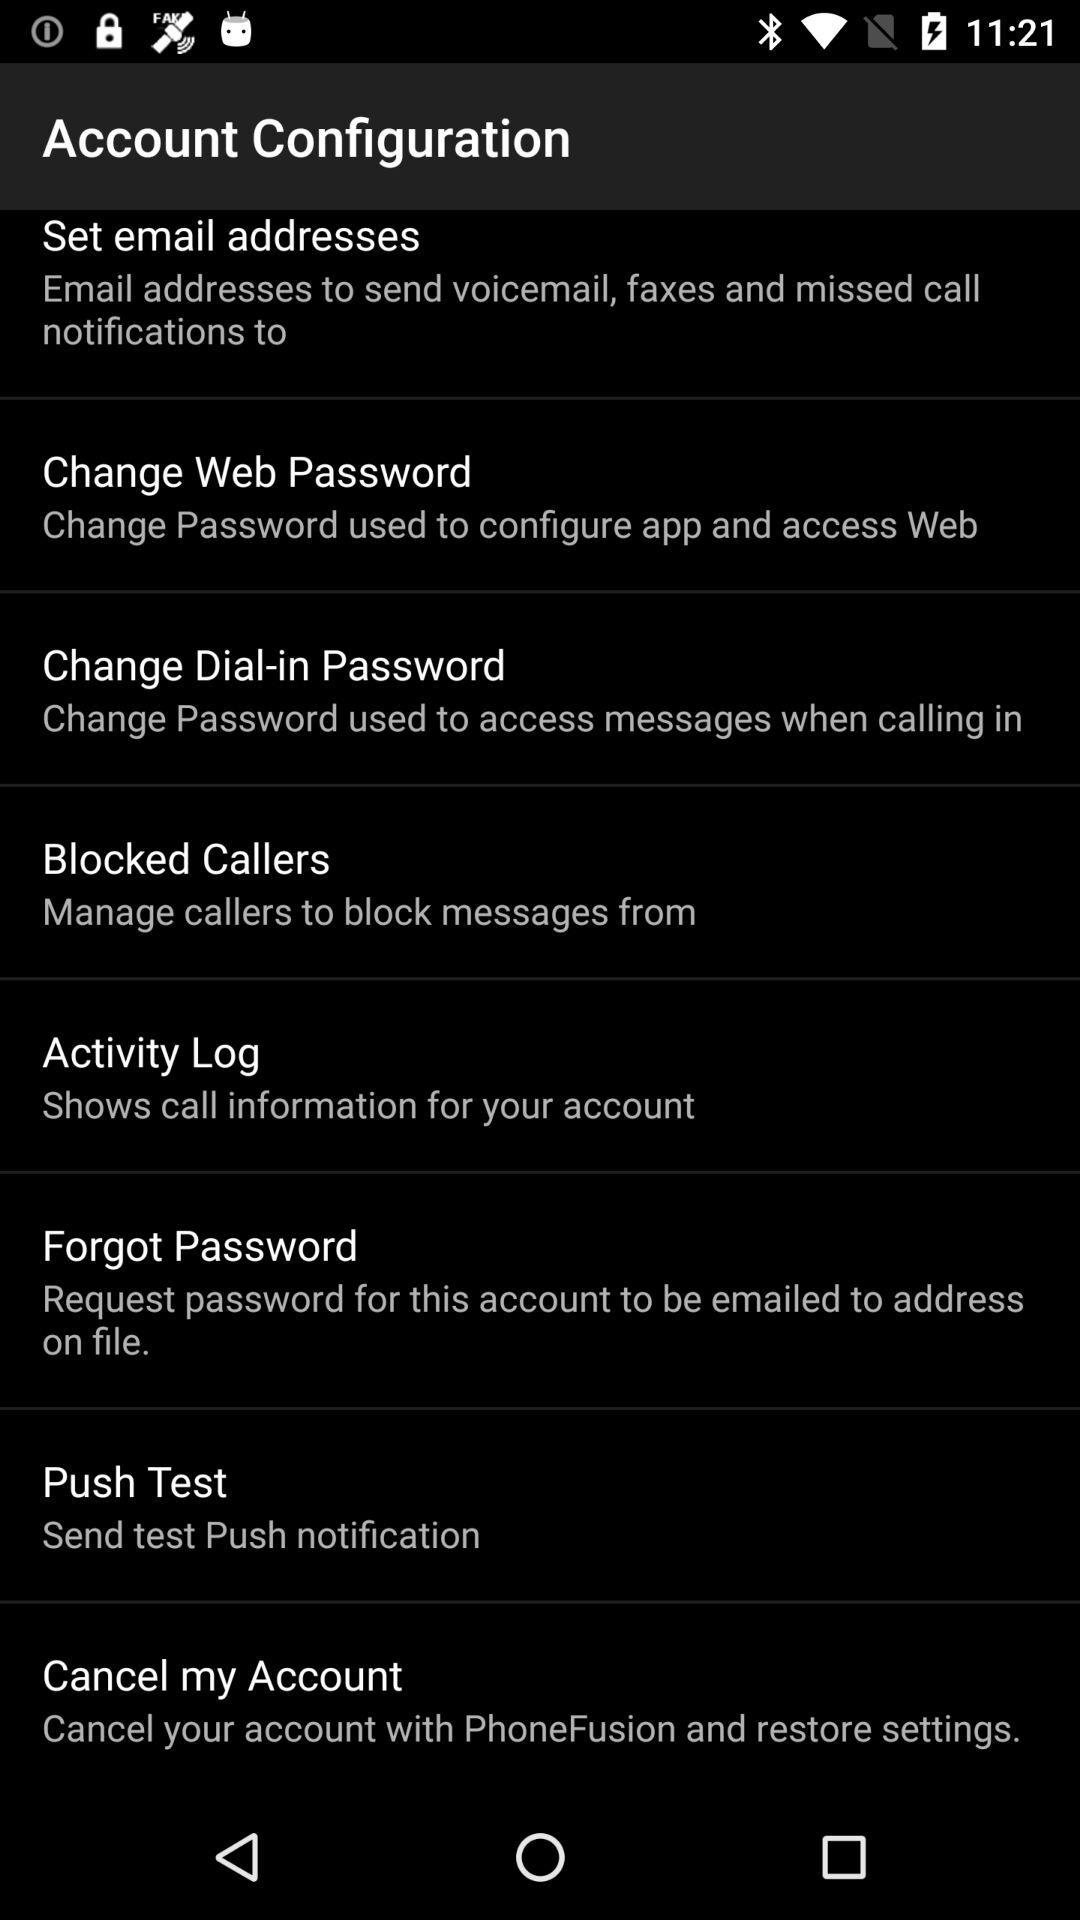How can I cancel my account? You can cancel your account with PhoneFusion. 